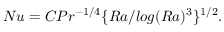Convert formula to latex. <formula><loc_0><loc_0><loc_500><loc_500>N u = C P r ^ { - 1 / 4 } \{ R a / \log ( R a ) ^ { 3 } \} ^ { 1 / 2 } .</formula> 